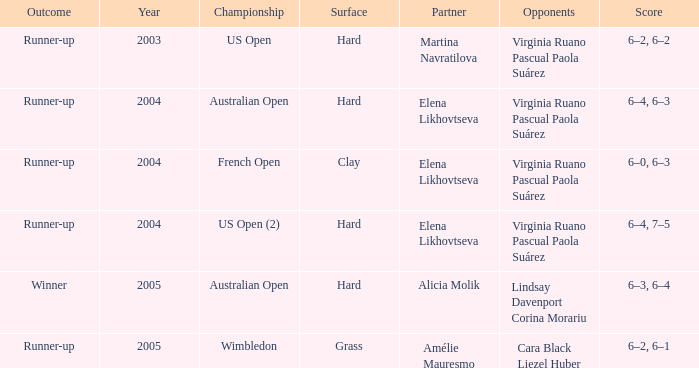When us open (2) is the championship what is the surface? Hard. 